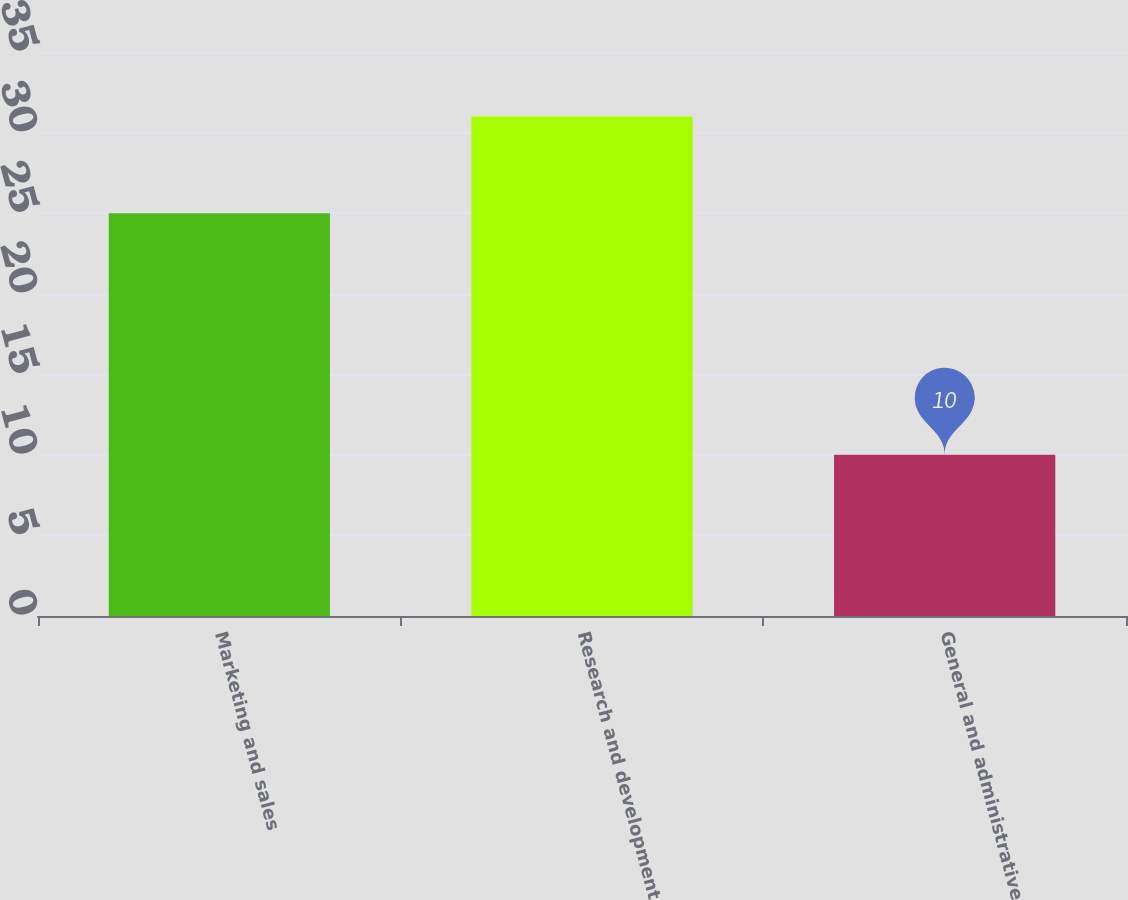Convert chart. <chart><loc_0><loc_0><loc_500><loc_500><bar_chart><fcel>Marketing and sales<fcel>Research and development<fcel>General and administrative<nl><fcel>25<fcel>31<fcel>10<nl></chart> 